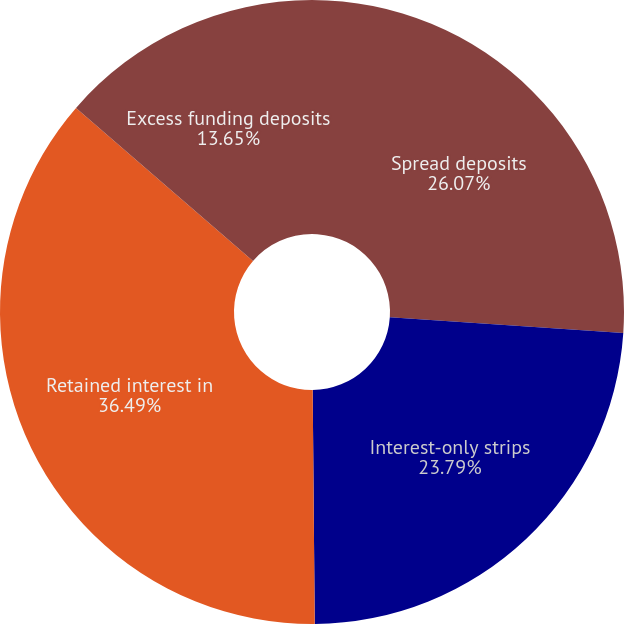<chart> <loc_0><loc_0><loc_500><loc_500><pie_chart><fcel>Spread deposits<fcel>Interest-only strips<fcel>Retained interest in<fcel>Excess funding deposits<nl><fcel>26.07%<fcel>23.79%<fcel>36.49%<fcel>13.65%<nl></chart> 